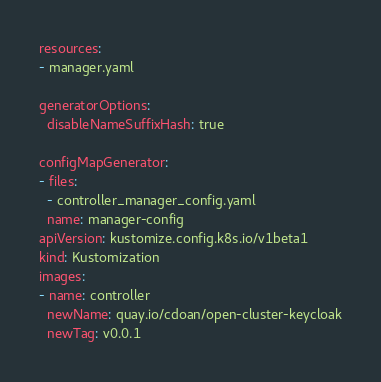Convert code to text. <code><loc_0><loc_0><loc_500><loc_500><_YAML_>resources:
- manager.yaml

generatorOptions:
  disableNameSuffixHash: true

configMapGenerator:
- files:
  - controller_manager_config.yaml
  name: manager-config
apiVersion: kustomize.config.k8s.io/v1beta1
kind: Kustomization
images:
- name: controller
  newName: quay.io/cdoan/open-cluster-keycloak
  newTag: v0.0.1
</code> 